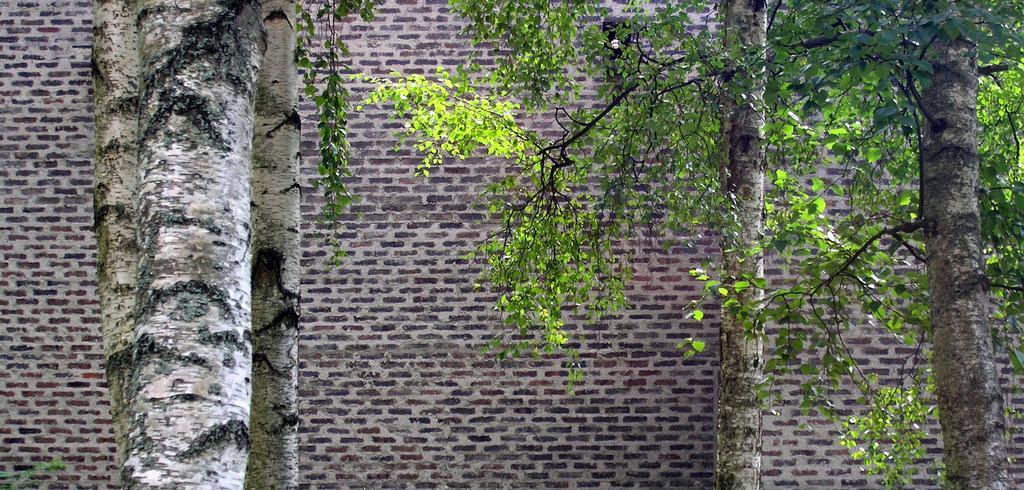In one or two sentences, can you explain what this image depicts? In the foreground of the picture there are trees. In the background there is a brick wall. 